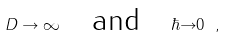<formula> <loc_0><loc_0><loc_500><loc_500>D \rightarrow \infty \quad \text {and} \quad \hbar { \rightarrow } 0 \ ,</formula> 